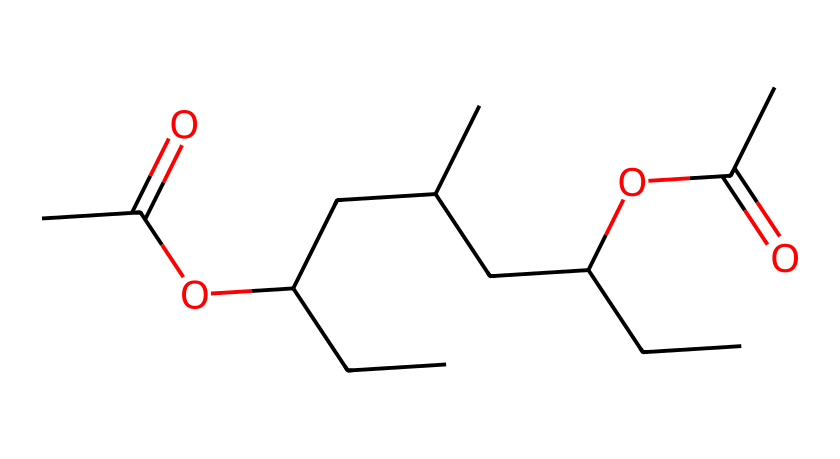What is the total number of carbon atoms in this chemical structure? By analyzing the SMILES representation, we can count the number of 'C' characters, which represent carbon atoms. In this structure, there are 12 'C' characters indicating there are 12 carbon atoms.
Answer: 12 How many ester functional groups are present in this chemical? The chemical structure contains 'C(=O)OC' segments, which indicate the presence of ester groups. There are 2 such segments in the structure, implying there are 2 ester functional groups.
Answer: 2 Is this chemical more likely to be hydrophobic or hydrophilic? The presence of large hydrocarbon chains (numerous carbon and hydrogen atoms) indicates a preference for hydrophobic characteristics. There are no highly polar functional groups present, further suggesting hydrophobicity.
Answer: hydrophobic What is the molecular formula based on the provided SMILES? From the breakdown of the SMILES, we have C12, H22, and O2 from the two ester groups. By counting the numbers of each type of atom, we can derive the molecular formula as C12H22O2.
Answer: C12H22O2 What type of polymer does this chemical represent? The presence of vinyl (indicated by the ethylene presence) and acetate functional groups suggests that this molecular structure represents a type of copolymer known as ethylene-vinyl acetate (EVA), commonly used in foams for cushioning.
Answer: ethylene-vinyl acetate How many oxygen atoms are shown in this chemical structure? In the SMILES representation, the 'O' letters signify oxygen atoms. There are 2 instances of 'O' in the chemical, which leads to the conclusion that there are 2 oxygen atoms present.
Answer: 2 